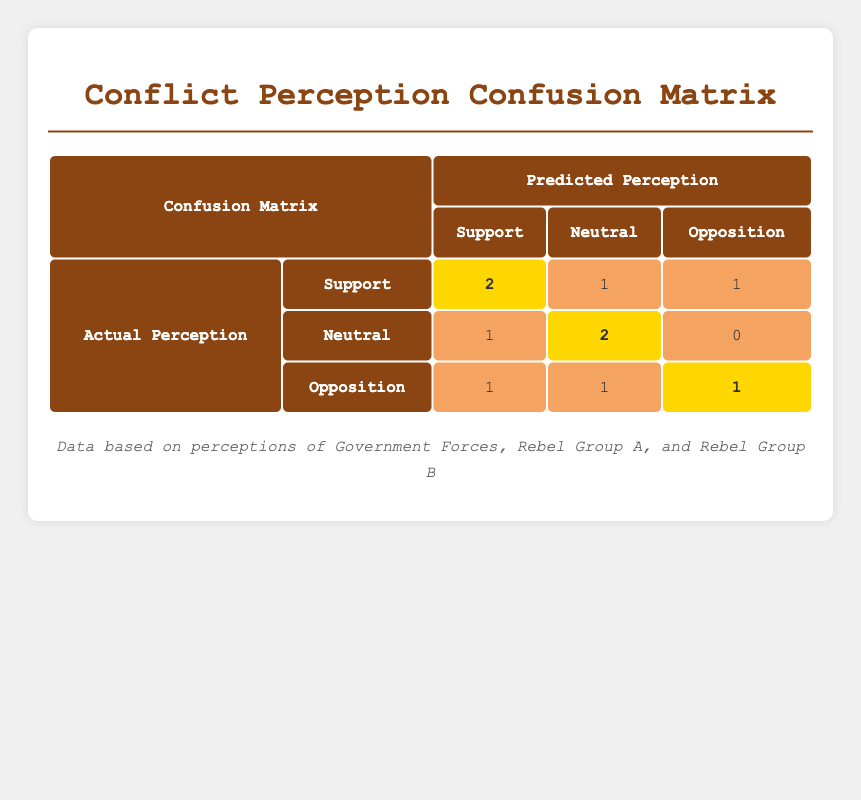What is the value for the actual perception of "Support" predicted as "Support"? Looking at the table, the cell where the actual perception is "Support" and the predicted perception is also "Support" indicates a value of 2.
Answer: 2 How many responses predicted "Neutral" when the actual perception was "Opposition"? In the row for actual perception "Opposition" and predicted perception "Neutral", the value is 1.
Answer: 1 What is the total number of predictions for the "Neutral" actual perceptions? Summing the predictions in the "Neutral" row: 1 (Support) + 2 (Neutral) + 0 (Opposition) = 3.
Answer: 3 Is there any discrepancy where respondents supported the "Government Forces" but predicted "Opposition"? Yes, in the row for "Government Forces" with actual opposition perception, there's one respondent who predicted "Support," indicating a discrepancy.
Answer: Yes Which group had the highest consistency between actual and predicted perceptions? Looking at the values for each group, "Rebel Group A" has 2 consistent (actual vs. predicted) perceptions (Neutral and Opposition) while others have more discrepancies, indicating less consistency.
Answer: Rebel Group A What is the total number of respondents who supported the "Rebel Group B"? In the table, looking at "Rebel Group B," the values are 1 (Support predicted) and 2 (which is not support) indicating a total of 1 for actual support.
Answer: 1 How many people predicted "Opposition" when the actual perception was "Support"? The row for actual perception "Support" shows a predicted value of 1 (Opposition), indicating 1 respondent predicted opposition for actual support perception.
Answer: 1 What is the value for the actual opposition perception predicted as "Opposition"? The cell for actual perception "Opposition" and predicted perception "Opposition" shows a value of 1.
Answer: 1 How does the total prediction of actual perceptions compare between "Support" and "Opposition"? For "Support," the total is 2+1+1=4. For "Opposition," the total is 1+1+1=3. So, support has more predictions than opposition in this dataset.
Answer: Support is greater 